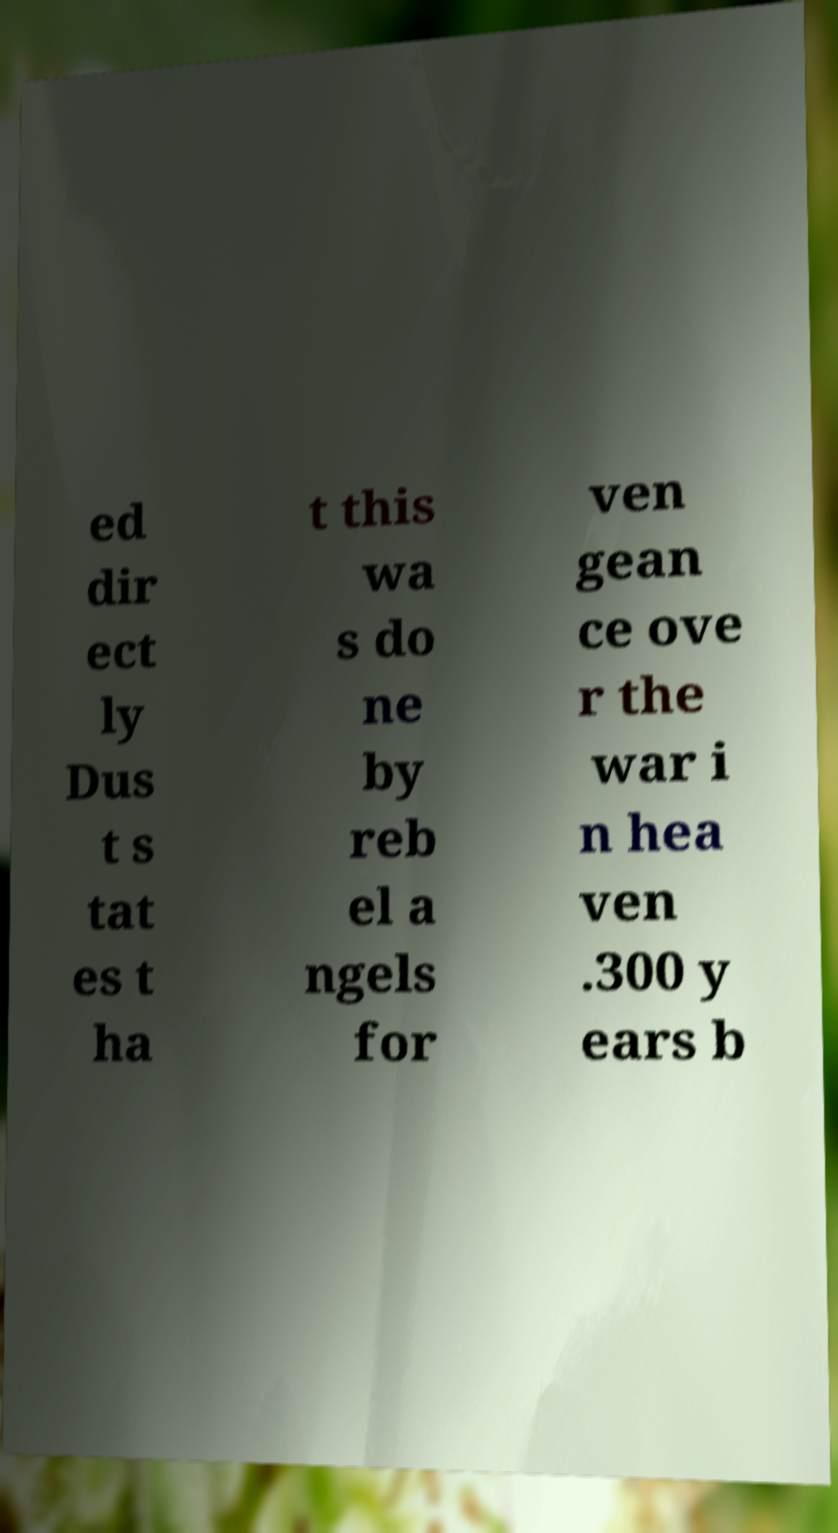Can you accurately transcribe the text from the provided image for me? ed dir ect ly Dus t s tat es t ha t this wa s do ne by reb el a ngels for ven gean ce ove r the war i n hea ven .300 y ears b 